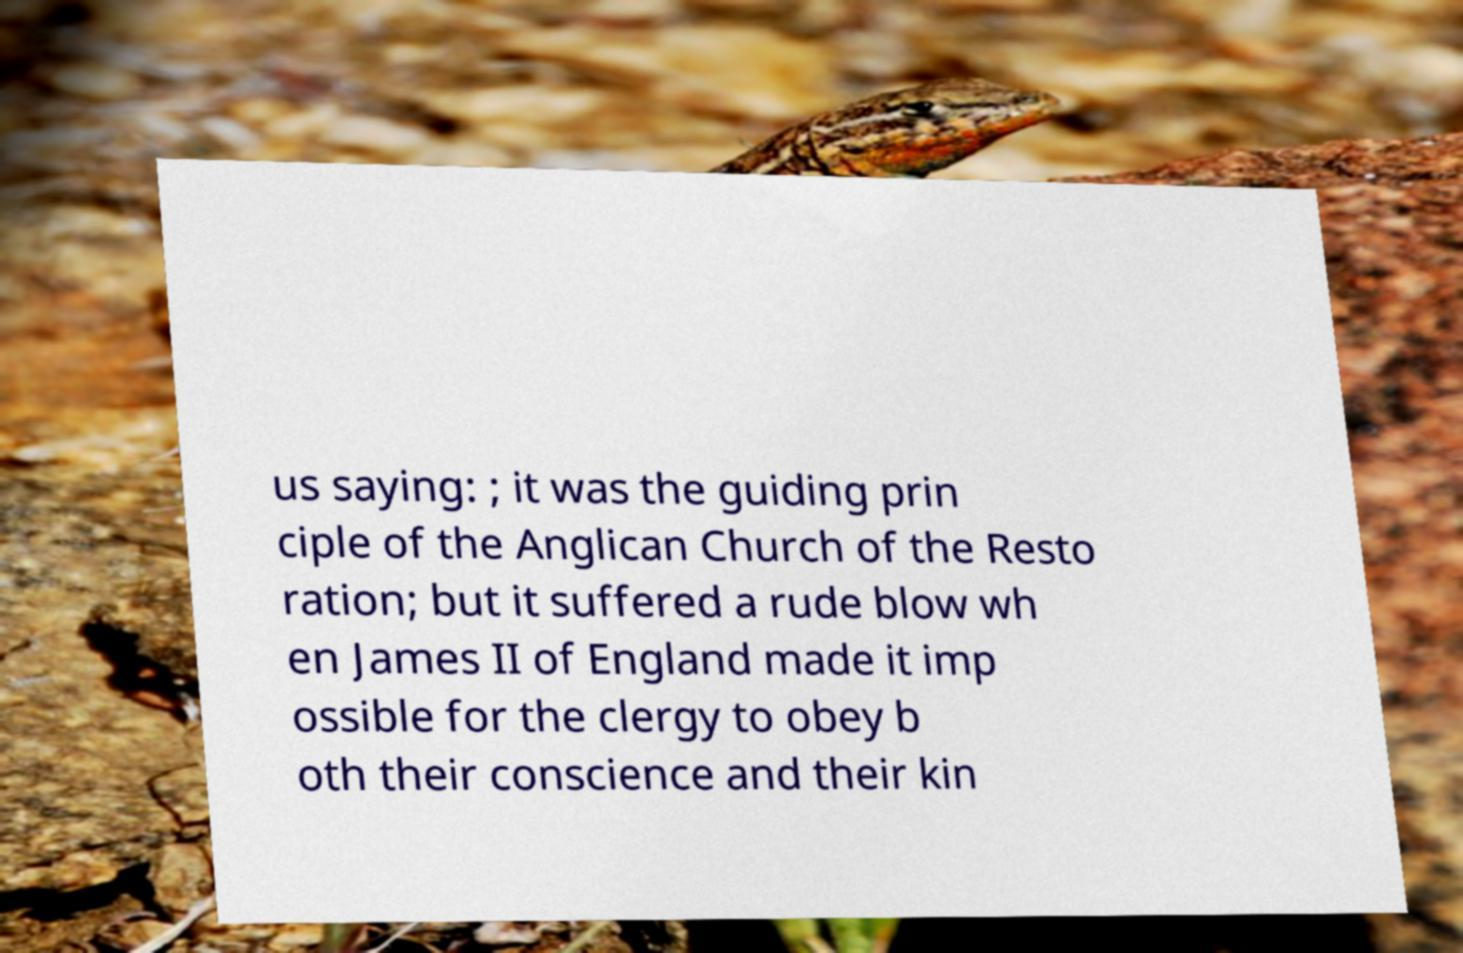There's text embedded in this image that I need extracted. Can you transcribe it verbatim? us saying: ; it was the guiding prin ciple of the Anglican Church of the Resto ration; but it suffered a rude blow wh en James II of England made it imp ossible for the clergy to obey b oth their conscience and their kin 